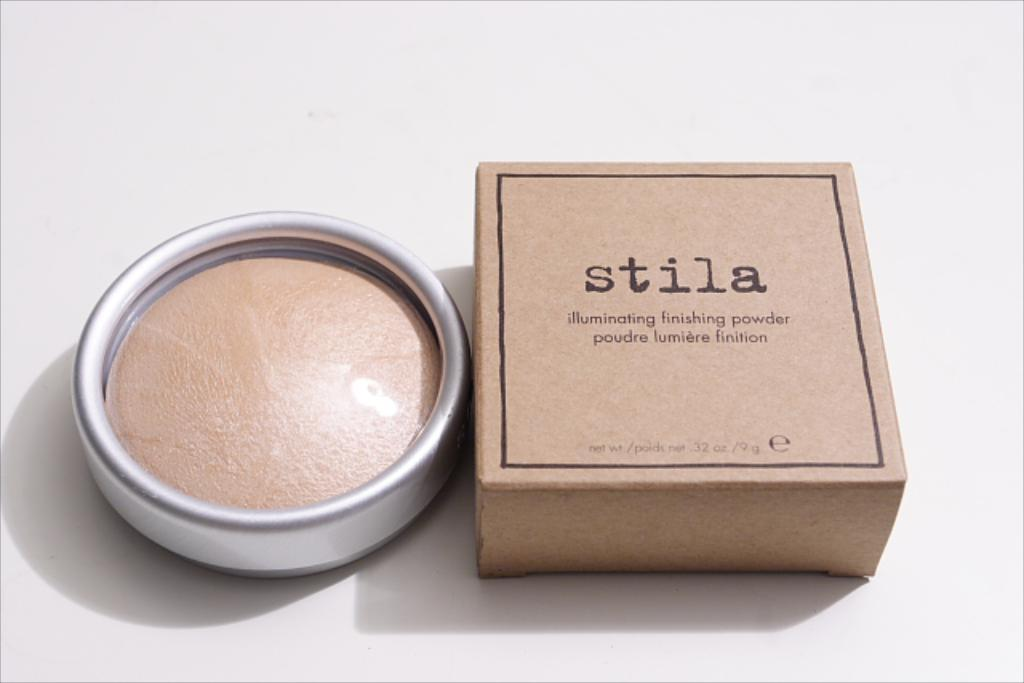<image>
Summarize the visual content of the image. a make up powder in a round container texted to a square box with the  name Stila on it. 